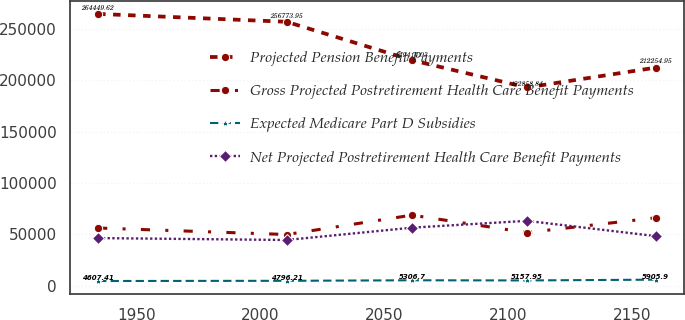Convert chart. <chart><loc_0><loc_0><loc_500><loc_500><line_chart><ecel><fcel>Projected Pension Benefit Payments<fcel>Gross Projected Postretirement Health Care Benefit Payments<fcel>Expected Medicare Part D Subsidies<fcel>Net Projected Postretirement Health Care Benefit Payments<nl><fcel>1934.53<fcel>264450<fcel>56159.8<fcel>4607.41<fcel>46363.9<nl><fcel>2010.59<fcel>256774<fcel>49832.1<fcel>4796.21<fcel>44499<nl><fcel>2061.11<fcel>219414<fcel>68681.2<fcel>5306.7<fcel>56482<nl><fcel>2107.45<fcel>192859<fcel>51717<fcel>5157.95<fcel>63147.8<nl><fcel>2159.58<fcel>212255<fcel>66113.4<fcel>5905.9<fcel>48228.8<nl></chart> 